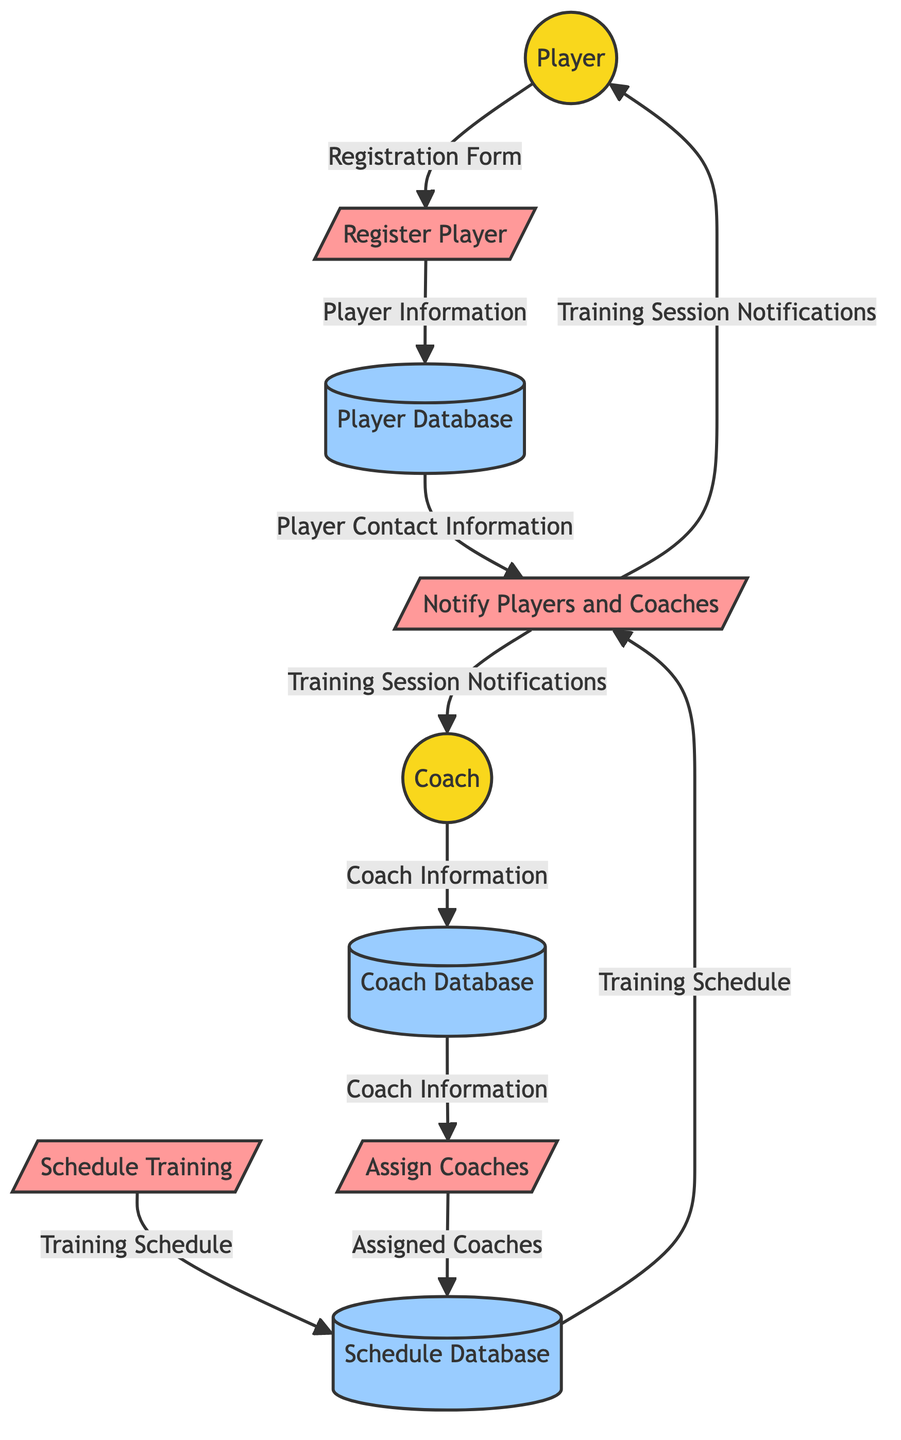What is the first process in the diagram? The first process in the diagram is labeled as "P1" and is called "Register Player." It is depicted at the top of the flowchart.
Answer: Register Player How many external entities are represented in the diagram? The diagram shows two external entities: Player and Coach. Each serves as a source for data entering the system.
Answer: 2 What is the purpose of Process P2? Process P2 is labeled "Schedule Training," and it is responsible for setting up training schedules for the academy. It connects to the Schedule Database.
Answer: Schedule Training Which data store contains player contact information? The Player Database (D1) is the data store that holds player information, including their contact details, which are used in the notification process.
Answer: Player Database What data does Coach provide to the Coach Database? The Coach provides "Coach Information" to the Coach Database (D3), which stores details about the coaching staff.
Answer: Coach Information Which process sends notifications to players and coaches? The process that sends notifications is "Notify Players and Coaches," labeled P4 in the diagram. It connects the Schedule Database and Player Database to the players and coaches.
Answer: Notify Players and Coaches What does Process P3 utilize from the Coach Database? Process P3, which is responsible for assigning coaches, utilizes "Coach Information" from the Coach Database (D3) to perform its function.
Answer: Coach Information Which database is connected to both Process P2 and Process P3? The Schedule Database (D2) is connected to both Process P2 for storing training schedules and Process P3 for assigning coaches.
Answer: Schedule Database How is player registration information treated in the system? The player registration information is collected through the "Registration Form," processed by "Register Player" (P1), and then stored in the Player Database (D1).
Answer: Player Information 